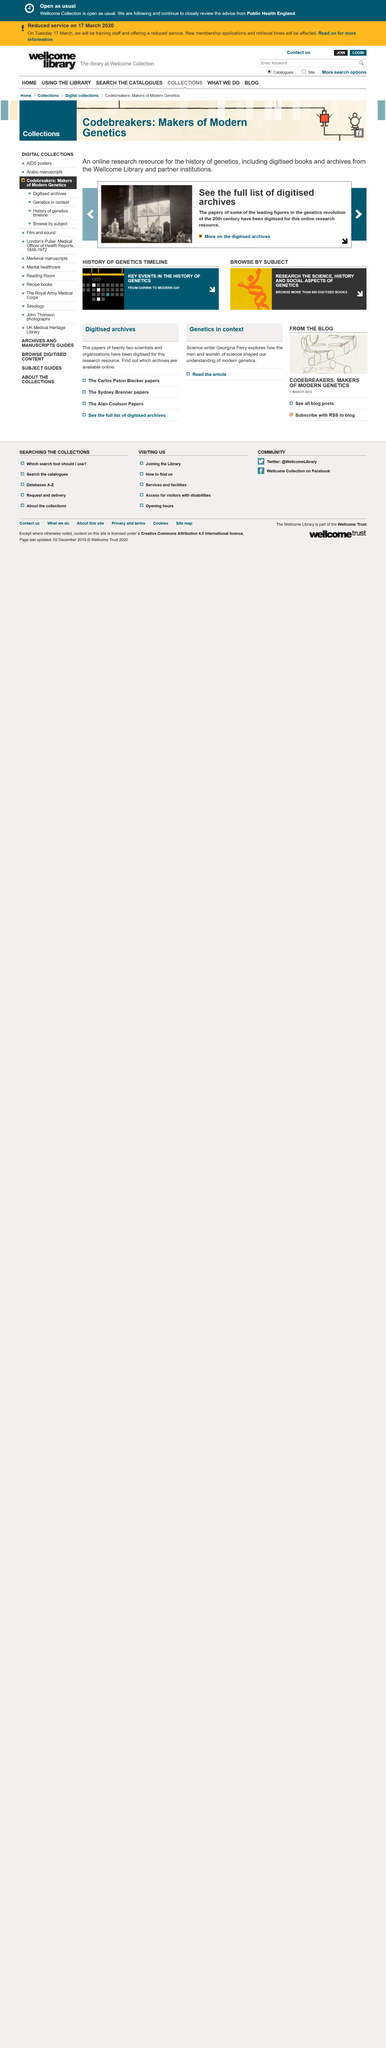Outline some significant characteristics in this image. Codebreakers: Makers of Modern Genetics is an online research resource for the history of genetics that provides access to a wealth of information and materials related to the history of genetics. The genetics revolution took place in the 20th century. The resource materials available in the archive consist of digitised books and archives. 